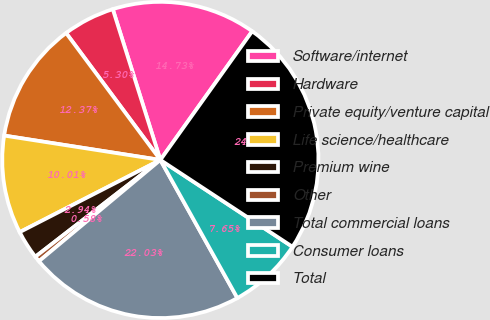Convert chart. <chart><loc_0><loc_0><loc_500><loc_500><pie_chart><fcel>Software/internet<fcel>Hardware<fcel>Private equity/venture capital<fcel>Life science/healthcare<fcel>Premium wine<fcel>Other<fcel>Total commercial loans<fcel>Consumer loans<fcel>Total<nl><fcel>14.73%<fcel>5.3%<fcel>12.37%<fcel>10.01%<fcel>2.94%<fcel>0.58%<fcel>22.03%<fcel>7.65%<fcel>24.39%<nl></chart> 